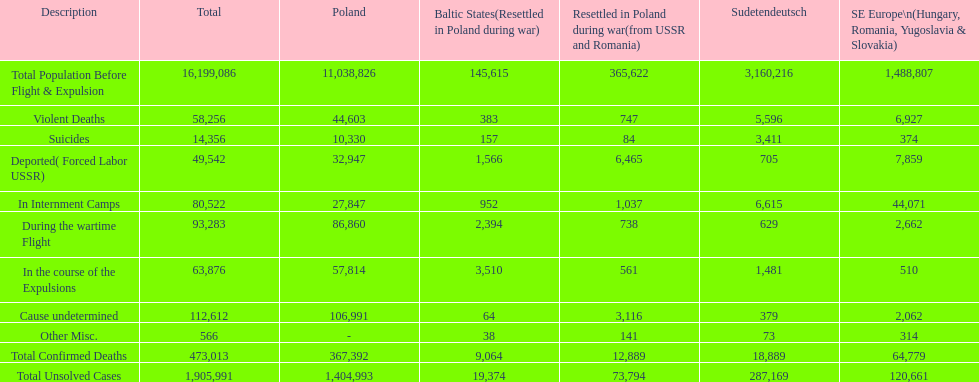Did the baltic states experience a higher number of undetermined or miscellaneous mortalities? Cause undetermined. 